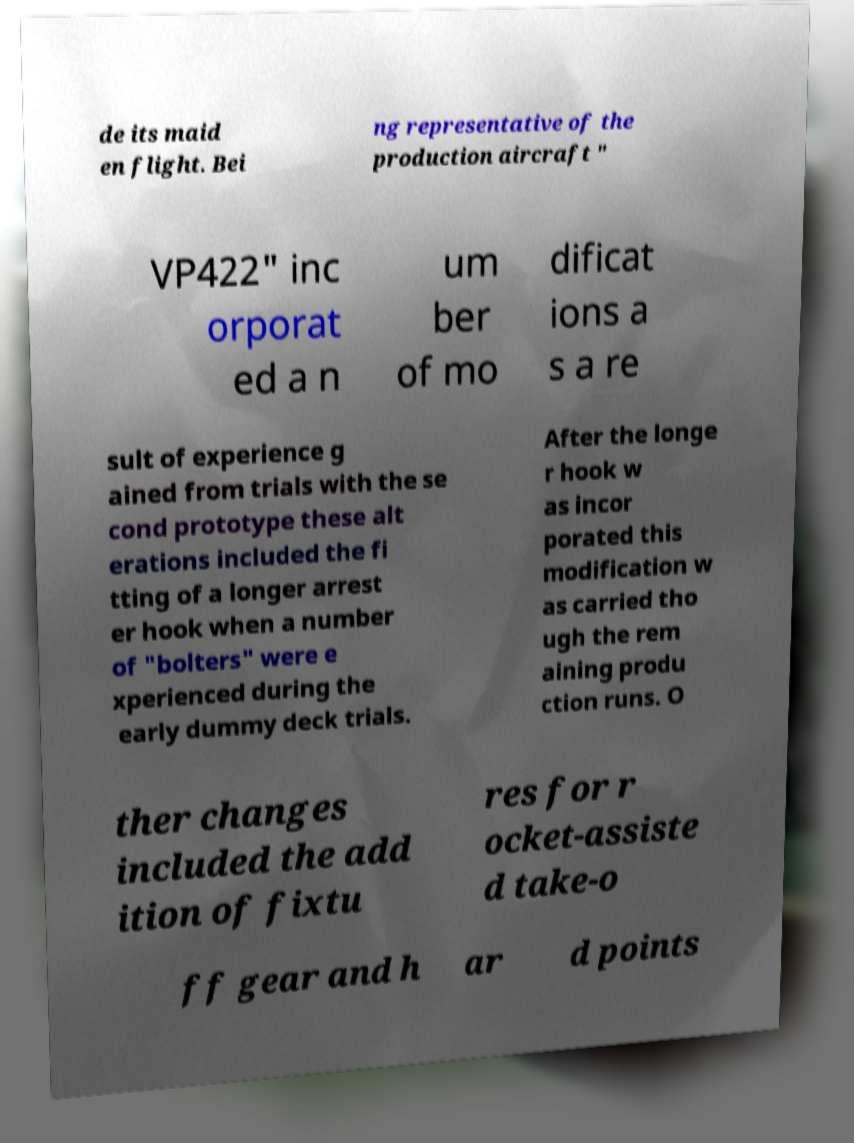I need the written content from this picture converted into text. Can you do that? de its maid en flight. Bei ng representative of the production aircraft " VP422" inc orporat ed a n um ber of mo dificat ions a s a re sult of experience g ained from trials with the se cond prototype these alt erations included the fi tting of a longer arrest er hook when a number of "bolters" were e xperienced during the early dummy deck trials. After the longe r hook w as incor porated this modification w as carried tho ugh the rem aining produ ction runs. O ther changes included the add ition of fixtu res for r ocket-assiste d take-o ff gear and h ar d points 